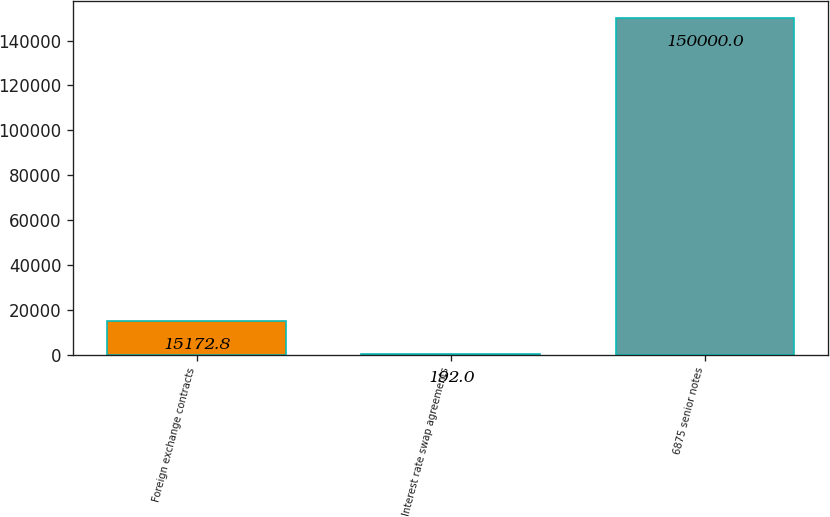Convert chart to OTSL. <chart><loc_0><loc_0><loc_500><loc_500><bar_chart><fcel>Foreign exchange contracts<fcel>Interest rate swap agreements<fcel>6875 senior notes<nl><fcel>15172.8<fcel>192<fcel>150000<nl></chart> 